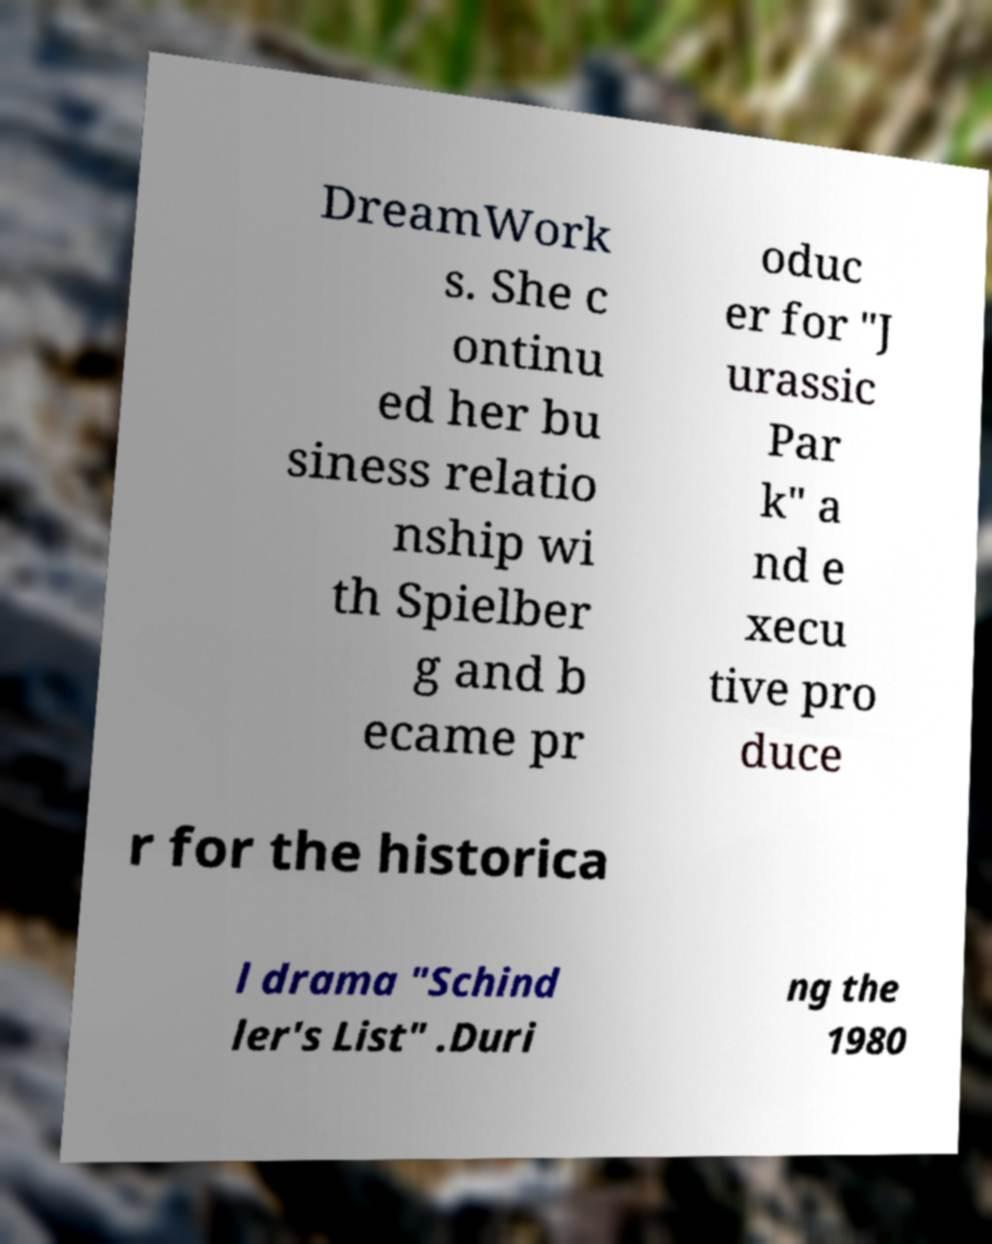I need the written content from this picture converted into text. Can you do that? DreamWork s. She c ontinu ed her bu siness relatio nship wi th Spielber g and b ecame pr oduc er for "J urassic Par k" a nd e xecu tive pro duce r for the historica l drama "Schind ler's List" .Duri ng the 1980 